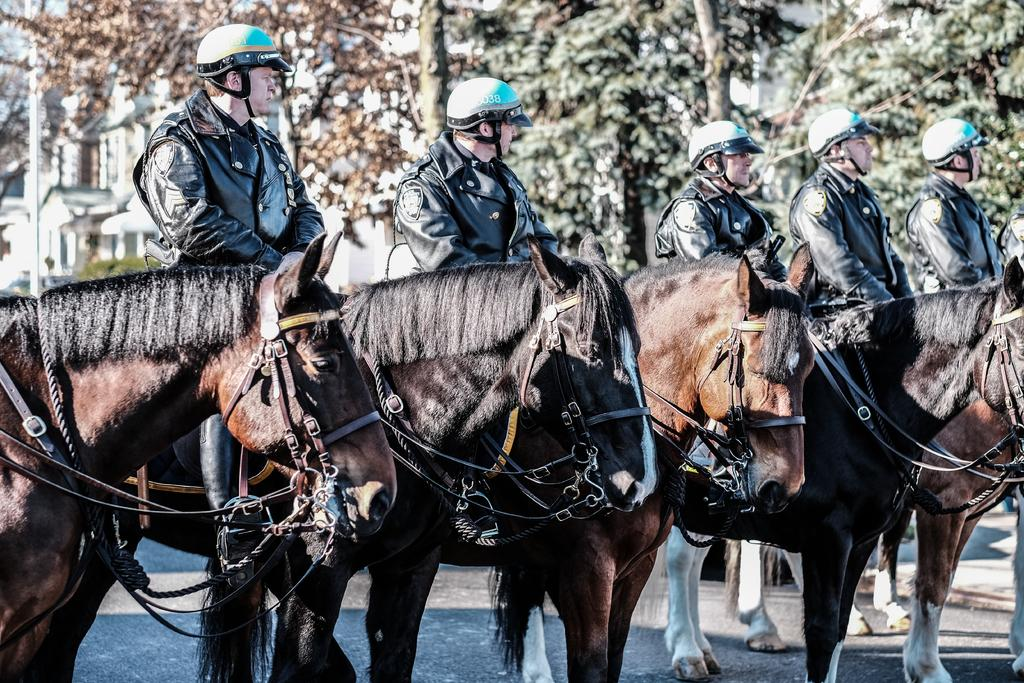What are the men in the image doing? The men in the image are sitting on horses. What are the men wearing on their heads? The men are wearing helmets. What can be seen in the background of the image? There are buildings, poles, bushes, and trees in the background of the image. How many babies are being pushed in strollers in the image? There are no babies or strollers present in the image. What type of weather can be inferred from the image based on the presence of thunder? There is no mention of thunder or any weather conditions in the image. 